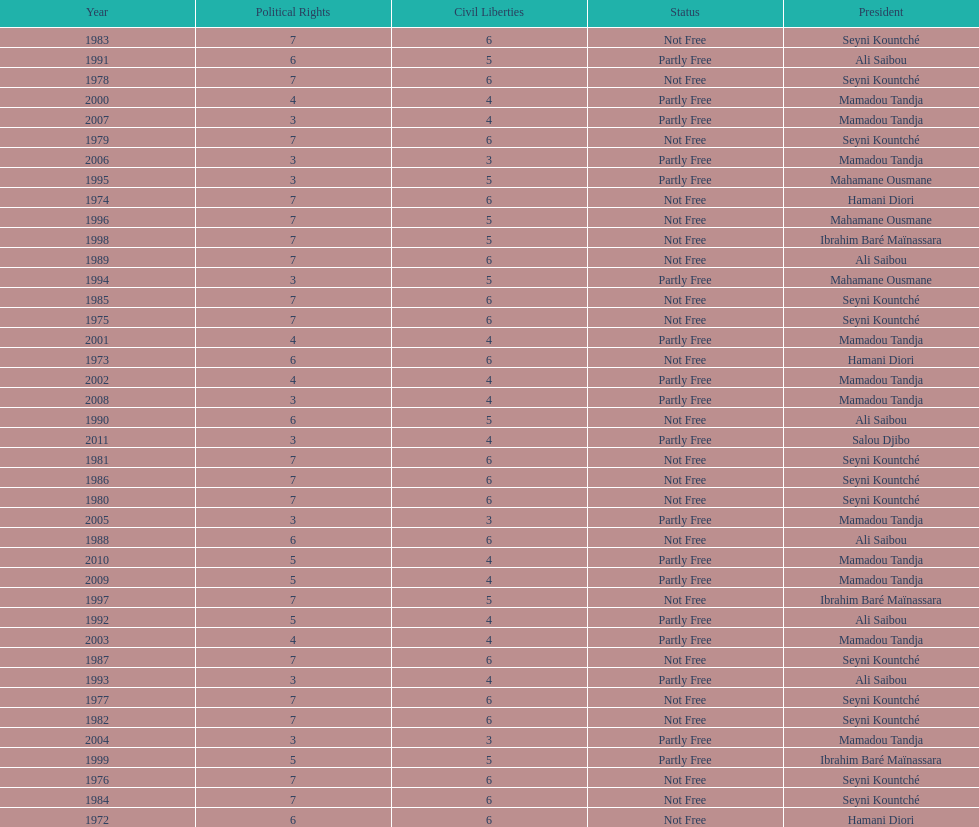How many times was the political rights listed as seven? 18. 